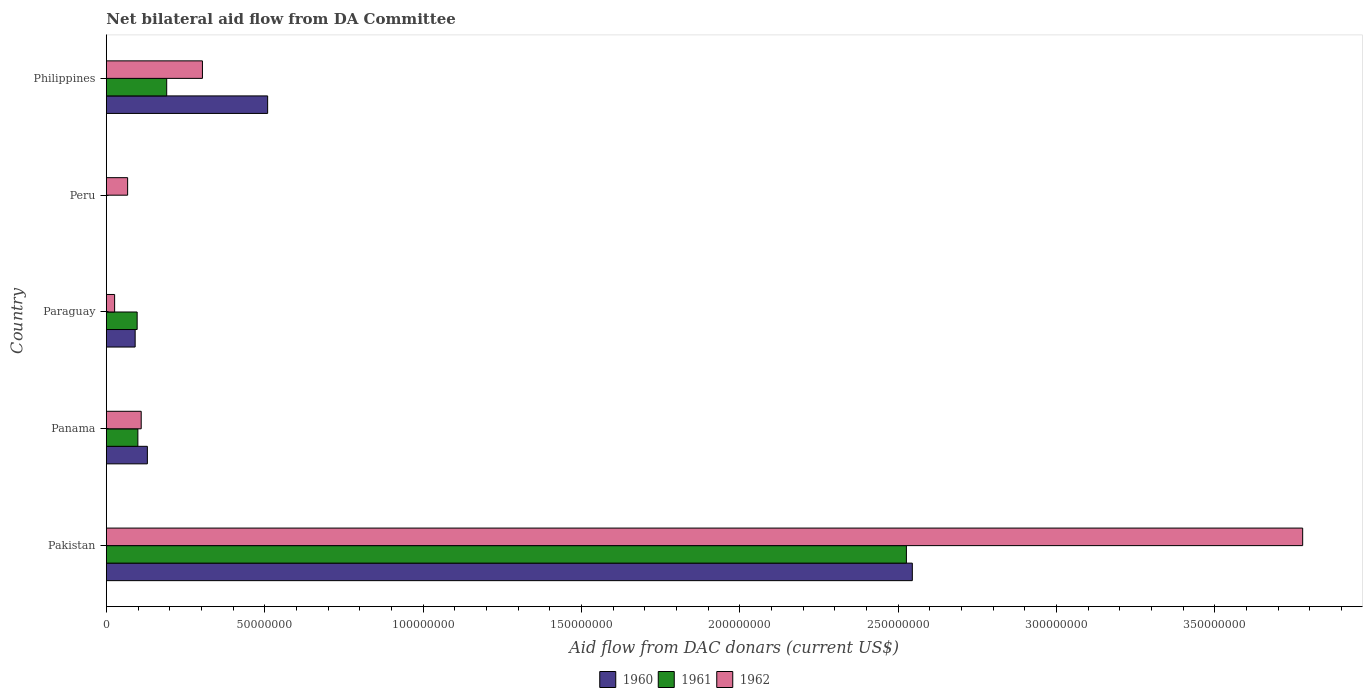How many different coloured bars are there?
Provide a short and direct response. 3. Are the number of bars per tick equal to the number of legend labels?
Your answer should be very brief. No. Are the number of bars on each tick of the Y-axis equal?
Your response must be concise. No. What is the label of the 4th group of bars from the top?
Provide a succinct answer. Panama. What is the aid flow in in 1960 in Pakistan?
Provide a succinct answer. 2.54e+08. Across all countries, what is the maximum aid flow in in 1961?
Your answer should be compact. 2.53e+08. In which country was the aid flow in in 1960 maximum?
Give a very brief answer. Pakistan. What is the total aid flow in in 1960 in the graph?
Keep it short and to the point. 3.27e+08. What is the difference between the aid flow in in 1962 in Pakistan and that in Paraguay?
Your response must be concise. 3.75e+08. What is the difference between the aid flow in in 1961 in Peru and the aid flow in in 1960 in Panama?
Provide a succinct answer. -1.30e+07. What is the average aid flow in in 1960 per country?
Give a very brief answer. 6.55e+07. What is the difference between the aid flow in in 1961 and aid flow in in 1960 in Philippines?
Offer a terse response. -3.19e+07. In how many countries, is the aid flow in in 1961 greater than 110000000 US$?
Ensure brevity in your answer.  1. What is the ratio of the aid flow in in 1960 in Pakistan to that in Paraguay?
Make the answer very short. 27.96. What is the difference between the highest and the second highest aid flow in in 1960?
Ensure brevity in your answer.  2.04e+08. What is the difference between the highest and the lowest aid flow in in 1960?
Offer a very short reply. 2.54e+08. In how many countries, is the aid flow in in 1962 greater than the average aid flow in in 1962 taken over all countries?
Your answer should be compact. 1. Is it the case that in every country, the sum of the aid flow in in 1960 and aid flow in in 1962 is greater than the aid flow in in 1961?
Provide a succinct answer. Yes. Are all the bars in the graph horizontal?
Provide a short and direct response. Yes. How many countries are there in the graph?
Your answer should be very brief. 5. What is the difference between two consecutive major ticks on the X-axis?
Ensure brevity in your answer.  5.00e+07. Are the values on the major ticks of X-axis written in scientific E-notation?
Ensure brevity in your answer.  No. Does the graph contain grids?
Provide a short and direct response. No. What is the title of the graph?
Your answer should be compact. Net bilateral aid flow from DA Committee. What is the label or title of the X-axis?
Provide a short and direct response. Aid flow from DAC donars (current US$). What is the Aid flow from DAC donars (current US$) of 1960 in Pakistan?
Your response must be concise. 2.54e+08. What is the Aid flow from DAC donars (current US$) of 1961 in Pakistan?
Your answer should be very brief. 2.53e+08. What is the Aid flow from DAC donars (current US$) of 1962 in Pakistan?
Provide a succinct answer. 3.78e+08. What is the Aid flow from DAC donars (current US$) in 1960 in Panama?
Provide a succinct answer. 1.30e+07. What is the Aid flow from DAC donars (current US$) in 1961 in Panama?
Give a very brief answer. 9.96e+06. What is the Aid flow from DAC donars (current US$) in 1962 in Panama?
Your answer should be very brief. 1.10e+07. What is the Aid flow from DAC donars (current US$) of 1960 in Paraguay?
Offer a very short reply. 9.10e+06. What is the Aid flow from DAC donars (current US$) in 1961 in Paraguay?
Your response must be concise. 9.73e+06. What is the Aid flow from DAC donars (current US$) of 1962 in Paraguay?
Your answer should be compact. 2.62e+06. What is the Aid flow from DAC donars (current US$) in 1960 in Peru?
Provide a succinct answer. 0. What is the Aid flow from DAC donars (current US$) in 1961 in Peru?
Offer a terse response. 0. What is the Aid flow from DAC donars (current US$) in 1962 in Peru?
Offer a very short reply. 6.72e+06. What is the Aid flow from DAC donars (current US$) in 1960 in Philippines?
Keep it short and to the point. 5.09e+07. What is the Aid flow from DAC donars (current US$) of 1961 in Philippines?
Ensure brevity in your answer.  1.91e+07. What is the Aid flow from DAC donars (current US$) in 1962 in Philippines?
Ensure brevity in your answer.  3.03e+07. Across all countries, what is the maximum Aid flow from DAC donars (current US$) of 1960?
Give a very brief answer. 2.54e+08. Across all countries, what is the maximum Aid flow from DAC donars (current US$) in 1961?
Make the answer very short. 2.53e+08. Across all countries, what is the maximum Aid flow from DAC donars (current US$) in 1962?
Offer a terse response. 3.78e+08. Across all countries, what is the minimum Aid flow from DAC donars (current US$) of 1960?
Make the answer very short. 0. Across all countries, what is the minimum Aid flow from DAC donars (current US$) of 1962?
Give a very brief answer. 2.62e+06. What is the total Aid flow from DAC donars (current US$) in 1960 in the graph?
Your answer should be very brief. 3.27e+08. What is the total Aid flow from DAC donars (current US$) of 1961 in the graph?
Your answer should be very brief. 2.91e+08. What is the total Aid flow from DAC donars (current US$) in 1962 in the graph?
Offer a terse response. 4.28e+08. What is the difference between the Aid flow from DAC donars (current US$) in 1960 in Pakistan and that in Panama?
Provide a succinct answer. 2.42e+08. What is the difference between the Aid flow from DAC donars (current US$) of 1961 in Pakistan and that in Panama?
Keep it short and to the point. 2.43e+08. What is the difference between the Aid flow from DAC donars (current US$) of 1962 in Pakistan and that in Panama?
Your answer should be very brief. 3.67e+08. What is the difference between the Aid flow from DAC donars (current US$) of 1960 in Pakistan and that in Paraguay?
Your answer should be very brief. 2.45e+08. What is the difference between the Aid flow from DAC donars (current US$) in 1961 in Pakistan and that in Paraguay?
Your answer should be very brief. 2.43e+08. What is the difference between the Aid flow from DAC donars (current US$) of 1962 in Pakistan and that in Paraguay?
Ensure brevity in your answer.  3.75e+08. What is the difference between the Aid flow from DAC donars (current US$) of 1962 in Pakistan and that in Peru?
Your response must be concise. 3.71e+08. What is the difference between the Aid flow from DAC donars (current US$) of 1960 in Pakistan and that in Philippines?
Provide a short and direct response. 2.04e+08. What is the difference between the Aid flow from DAC donars (current US$) of 1961 in Pakistan and that in Philippines?
Your answer should be compact. 2.34e+08. What is the difference between the Aid flow from DAC donars (current US$) of 1962 in Pakistan and that in Philippines?
Offer a very short reply. 3.47e+08. What is the difference between the Aid flow from DAC donars (current US$) in 1960 in Panama and that in Paraguay?
Your answer should be compact. 3.86e+06. What is the difference between the Aid flow from DAC donars (current US$) of 1961 in Panama and that in Paraguay?
Ensure brevity in your answer.  2.30e+05. What is the difference between the Aid flow from DAC donars (current US$) of 1962 in Panama and that in Paraguay?
Keep it short and to the point. 8.39e+06. What is the difference between the Aid flow from DAC donars (current US$) of 1962 in Panama and that in Peru?
Offer a terse response. 4.29e+06. What is the difference between the Aid flow from DAC donars (current US$) in 1960 in Panama and that in Philippines?
Keep it short and to the point. -3.80e+07. What is the difference between the Aid flow from DAC donars (current US$) of 1961 in Panama and that in Philippines?
Your answer should be compact. -9.10e+06. What is the difference between the Aid flow from DAC donars (current US$) in 1962 in Panama and that in Philippines?
Provide a succinct answer. -1.93e+07. What is the difference between the Aid flow from DAC donars (current US$) of 1962 in Paraguay and that in Peru?
Offer a terse response. -4.10e+06. What is the difference between the Aid flow from DAC donars (current US$) of 1960 in Paraguay and that in Philippines?
Your answer should be very brief. -4.18e+07. What is the difference between the Aid flow from DAC donars (current US$) of 1961 in Paraguay and that in Philippines?
Your response must be concise. -9.33e+06. What is the difference between the Aid flow from DAC donars (current US$) in 1962 in Paraguay and that in Philippines?
Your answer should be compact. -2.77e+07. What is the difference between the Aid flow from DAC donars (current US$) of 1962 in Peru and that in Philippines?
Your answer should be compact. -2.36e+07. What is the difference between the Aid flow from DAC donars (current US$) in 1960 in Pakistan and the Aid flow from DAC donars (current US$) in 1961 in Panama?
Offer a very short reply. 2.45e+08. What is the difference between the Aid flow from DAC donars (current US$) in 1960 in Pakistan and the Aid flow from DAC donars (current US$) in 1962 in Panama?
Your answer should be very brief. 2.43e+08. What is the difference between the Aid flow from DAC donars (current US$) in 1961 in Pakistan and the Aid flow from DAC donars (current US$) in 1962 in Panama?
Give a very brief answer. 2.42e+08. What is the difference between the Aid flow from DAC donars (current US$) in 1960 in Pakistan and the Aid flow from DAC donars (current US$) in 1961 in Paraguay?
Make the answer very short. 2.45e+08. What is the difference between the Aid flow from DAC donars (current US$) in 1960 in Pakistan and the Aid flow from DAC donars (current US$) in 1962 in Paraguay?
Offer a terse response. 2.52e+08. What is the difference between the Aid flow from DAC donars (current US$) in 1961 in Pakistan and the Aid flow from DAC donars (current US$) in 1962 in Paraguay?
Offer a terse response. 2.50e+08. What is the difference between the Aid flow from DAC donars (current US$) in 1960 in Pakistan and the Aid flow from DAC donars (current US$) in 1962 in Peru?
Your response must be concise. 2.48e+08. What is the difference between the Aid flow from DAC donars (current US$) in 1961 in Pakistan and the Aid flow from DAC donars (current US$) in 1962 in Peru?
Provide a succinct answer. 2.46e+08. What is the difference between the Aid flow from DAC donars (current US$) in 1960 in Pakistan and the Aid flow from DAC donars (current US$) in 1961 in Philippines?
Make the answer very short. 2.35e+08. What is the difference between the Aid flow from DAC donars (current US$) of 1960 in Pakistan and the Aid flow from DAC donars (current US$) of 1962 in Philippines?
Your response must be concise. 2.24e+08. What is the difference between the Aid flow from DAC donars (current US$) of 1961 in Pakistan and the Aid flow from DAC donars (current US$) of 1962 in Philippines?
Keep it short and to the point. 2.22e+08. What is the difference between the Aid flow from DAC donars (current US$) of 1960 in Panama and the Aid flow from DAC donars (current US$) of 1961 in Paraguay?
Your answer should be compact. 3.23e+06. What is the difference between the Aid flow from DAC donars (current US$) of 1960 in Panama and the Aid flow from DAC donars (current US$) of 1962 in Paraguay?
Your answer should be compact. 1.03e+07. What is the difference between the Aid flow from DAC donars (current US$) in 1961 in Panama and the Aid flow from DAC donars (current US$) in 1962 in Paraguay?
Your answer should be compact. 7.34e+06. What is the difference between the Aid flow from DAC donars (current US$) in 1960 in Panama and the Aid flow from DAC donars (current US$) in 1962 in Peru?
Provide a short and direct response. 6.24e+06. What is the difference between the Aid flow from DAC donars (current US$) in 1961 in Panama and the Aid flow from DAC donars (current US$) in 1962 in Peru?
Ensure brevity in your answer.  3.24e+06. What is the difference between the Aid flow from DAC donars (current US$) of 1960 in Panama and the Aid flow from DAC donars (current US$) of 1961 in Philippines?
Provide a short and direct response. -6.10e+06. What is the difference between the Aid flow from DAC donars (current US$) of 1960 in Panama and the Aid flow from DAC donars (current US$) of 1962 in Philippines?
Ensure brevity in your answer.  -1.74e+07. What is the difference between the Aid flow from DAC donars (current US$) of 1961 in Panama and the Aid flow from DAC donars (current US$) of 1962 in Philippines?
Make the answer very short. -2.04e+07. What is the difference between the Aid flow from DAC donars (current US$) of 1960 in Paraguay and the Aid flow from DAC donars (current US$) of 1962 in Peru?
Provide a short and direct response. 2.38e+06. What is the difference between the Aid flow from DAC donars (current US$) of 1961 in Paraguay and the Aid flow from DAC donars (current US$) of 1962 in Peru?
Provide a short and direct response. 3.01e+06. What is the difference between the Aid flow from DAC donars (current US$) in 1960 in Paraguay and the Aid flow from DAC donars (current US$) in 1961 in Philippines?
Your answer should be compact. -9.96e+06. What is the difference between the Aid flow from DAC donars (current US$) in 1960 in Paraguay and the Aid flow from DAC donars (current US$) in 1962 in Philippines?
Your answer should be very brief. -2.12e+07. What is the difference between the Aid flow from DAC donars (current US$) in 1961 in Paraguay and the Aid flow from DAC donars (current US$) in 1962 in Philippines?
Your response must be concise. -2.06e+07. What is the average Aid flow from DAC donars (current US$) in 1960 per country?
Make the answer very short. 6.55e+07. What is the average Aid flow from DAC donars (current US$) of 1961 per country?
Offer a very short reply. 5.83e+07. What is the average Aid flow from DAC donars (current US$) of 1962 per country?
Ensure brevity in your answer.  8.57e+07. What is the difference between the Aid flow from DAC donars (current US$) in 1960 and Aid flow from DAC donars (current US$) in 1961 in Pakistan?
Provide a short and direct response. 1.87e+06. What is the difference between the Aid flow from DAC donars (current US$) in 1960 and Aid flow from DAC donars (current US$) in 1962 in Pakistan?
Provide a short and direct response. -1.23e+08. What is the difference between the Aid flow from DAC donars (current US$) in 1961 and Aid flow from DAC donars (current US$) in 1962 in Pakistan?
Make the answer very short. -1.25e+08. What is the difference between the Aid flow from DAC donars (current US$) in 1960 and Aid flow from DAC donars (current US$) in 1961 in Panama?
Your answer should be very brief. 3.00e+06. What is the difference between the Aid flow from DAC donars (current US$) of 1960 and Aid flow from DAC donars (current US$) of 1962 in Panama?
Offer a very short reply. 1.95e+06. What is the difference between the Aid flow from DAC donars (current US$) of 1961 and Aid flow from DAC donars (current US$) of 1962 in Panama?
Your response must be concise. -1.05e+06. What is the difference between the Aid flow from DAC donars (current US$) in 1960 and Aid flow from DAC donars (current US$) in 1961 in Paraguay?
Make the answer very short. -6.30e+05. What is the difference between the Aid flow from DAC donars (current US$) of 1960 and Aid flow from DAC donars (current US$) of 1962 in Paraguay?
Your answer should be compact. 6.48e+06. What is the difference between the Aid flow from DAC donars (current US$) in 1961 and Aid flow from DAC donars (current US$) in 1962 in Paraguay?
Make the answer very short. 7.11e+06. What is the difference between the Aid flow from DAC donars (current US$) of 1960 and Aid flow from DAC donars (current US$) of 1961 in Philippines?
Your answer should be compact. 3.19e+07. What is the difference between the Aid flow from DAC donars (current US$) in 1960 and Aid flow from DAC donars (current US$) in 1962 in Philippines?
Your response must be concise. 2.06e+07. What is the difference between the Aid flow from DAC donars (current US$) in 1961 and Aid flow from DAC donars (current US$) in 1962 in Philippines?
Offer a terse response. -1.13e+07. What is the ratio of the Aid flow from DAC donars (current US$) of 1960 in Pakistan to that in Panama?
Your answer should be compact. 19.64. What is the ratio of the Aid flow from DAC donars (current US$) of 1961 in Pakistan to that in Panama?
Provide a short and direct response. 25.36. What is the ratio of the Aid flow from DAC donars (current US$) in 1962 in Pakistan to that in Panama?
Ensure brevity in your answer.  34.31. What is the ratio of the Aid flow from DAC donars (current US$) in 1960 in Pakistan to that in Paraguay?
Keep it short and to the point. 27.96. What is the ratio of the Aid flow from DAC donars (current US$) in 1961 in Pakistan to that in Paraguay?
Offer a very short reply. 25.96. What is the ratio of the Aid flow from DAC donars (current US$) in 1962 in Pakistan to that in Paraguay?
Ensure brevity in your answer.  144.16. What is the ratio of the Aid flow from DAC donars (current US$) in 1962 in Pakistan to that in Peru?
Ensure brevity in your answer.  56.21. What is the ratio of the Aid flow from DAC donars (current US$) in 1960 in Pakistan to that in Philippines?
Your answer should be compact. 5. What is the ratio of the Aid flow from DAC donars (current US$) of 1961 in Pakistan to that in Philippines?
Ensure brevity in your answer.  13.25. What is the ratio of the Aid flow from DAC donars (current US$) in 1962 in Pakistan to that in Philippines?
Your response must be concise. 12.45. What is the ratio of the Aid flow from DAC donars (current US$) in 1960 in Panama to that in Paraguay?
Make the answer very short. 1.42. What is the ratio of the Aid flow from DAC donars (current US$) of 1961 in Panama to that in Paraguay?
Ensure brevity in your answer.  1.02. What is the ratio of the Aid flow from DAC donars (current US$) of 1962 in Panama to that in Paraguay?
Offer a very short reply. 4.2. What is the ratio of the Aid flow from DAC donars (current US$) of 1962 in Panama to that in Peru?
Keep it short and to the point. 1.64. What is the ratio of the Aid flow from DAC donars (current US$) in 1960 in Panama to that in Philippines?
Give a very brief answer. 0.25. What is the ratio of the Aid flow from DAC donars (current US$) in 1961 in Panama to that in Philippines?
Offer a terse response. 0.52. What is the ratio of the Aid flow from DAC donars (current US$) in 1962 in Panama to that in Philippines?
Provide a short and direct response. 0.36. What is the ratio of the Aid flow from DAC donars (current US$) in 1962 in Paraguay to that in Peru?
Your answer should be very brief. 0.39. What is the ratio of the Aid flow from DAC donars (current US$) in 1960 in Paraguay to that in Philippines?
Give a very brief answer. 0.18. What is the ratio of the Aid flow from DAC donars (current US$) of 1961 in Paraguay to that in Philippines?
Provide a short and direct response. 0.51. What is the ratio of the Aid flow from DAC donars (current US$) of 1962 in Paraguay to that in Philippines?
Give a very brief answer. 0.09. What is the ratio of the Aid flow from DAC donars (current US$) of 1962 in Peru to that in Philippines?
Your answer should be compact. 0.22. What is the difference between the highest and the second highest Aid flow from DAC donars (current US$) of 1960?
Keep it short and to the point. 2.04e+08. What is the difference between the highest and the second highest Aid flow from DAC donars (current US$) of 1961?
Your answer should be very brief. 2.34e+08. What is the difference between the highest and the second highest Aid flow from DAC donars (current US$) of 1962?
Your answer should be compact. 3.47e+08. What is the difference between the highest and the lowest Aid flow from DAC donars (current US$) of 1960?
Offer a terse response. 2.54e+08. What is the difference between the highest and the lowest Aid flow from DAC donars (current US$) of 1961?
Make the answer very short. 2.53e+08. What is the difference between the highest and the lowest Aid flow from DAC donars (current US$) in 1962?
Give a very brief answer. 3.75e+08. 